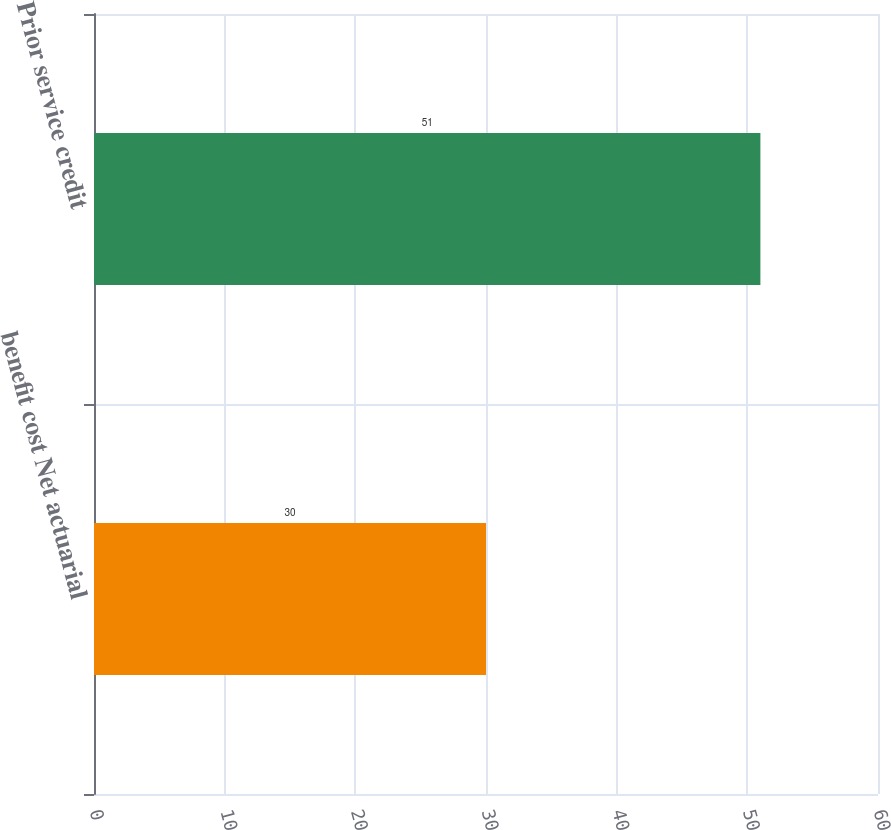Convert chart. <chart><loc_0><loc_0><loc_500><loc_500><bar_chart><fcel>benefit cost Net actuarial<fcel>Prior service credit<nl><fcel>30<fcel>51<nl></chart> 